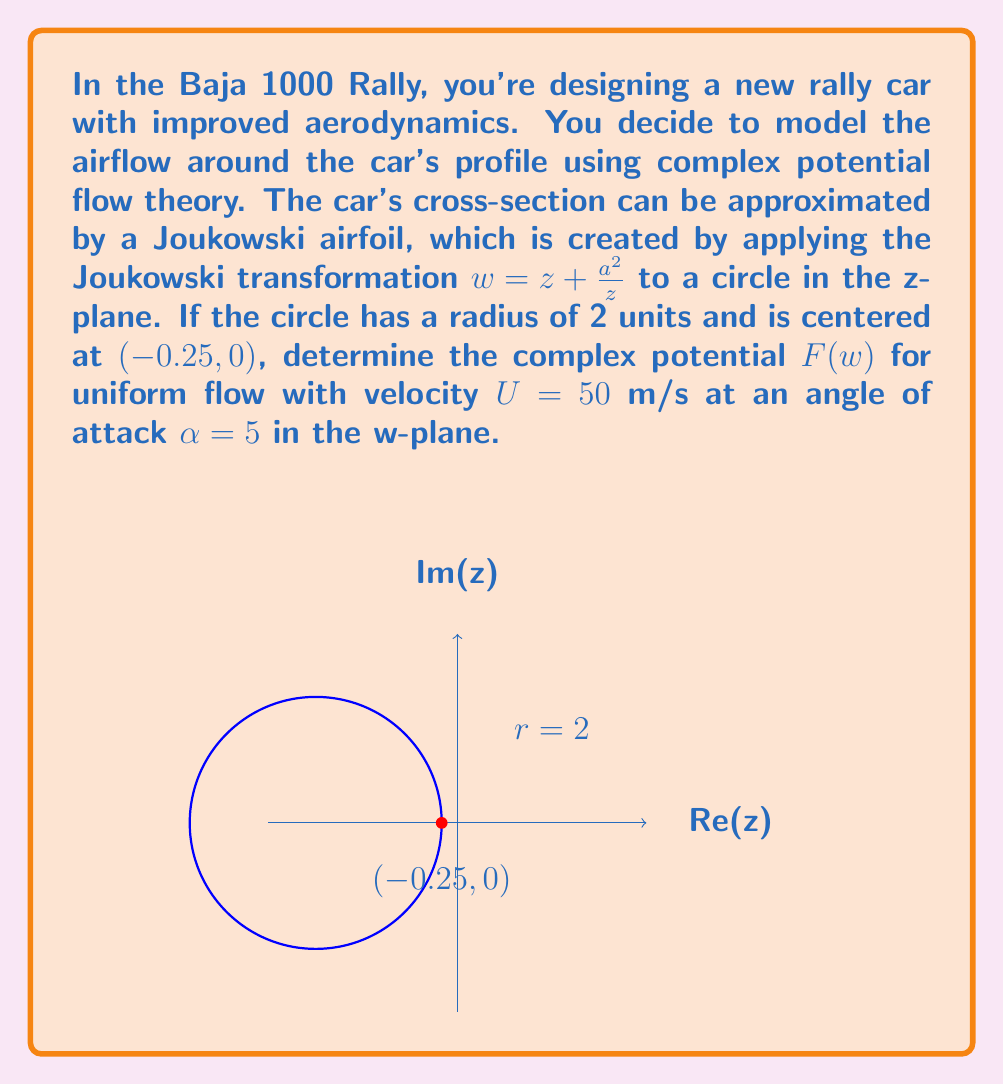Can you solve this math problem? Let's approach this step-by-step:

1) First, we need to find the complex potential in the z-plane. For uniform flow around a circle, the complex potential is given by:

   $$F(z) = U(z e^{-i\alpha} + \frac{R^2}{z} e^{i\alpha})$$

   where R is the radius of the circle and $\alpha$ is the angle of attack.

2) In our case, R = 2, U = 50 m/s, and $\alpha = 5° = \frac{\pi}{36}$ radians.

3) Substituting these values:

   $$F(z) = 50(z e^{-i\pi/36} + \frac{4}{z} e^{i\pi/36})$$

4) Now, we need to transform this to the w-plane using the Joukowski transformation:

   $$w = z + \frac{a^2}{z}$$

5) To find 'a', we use the fact that the circle is centered at (-0.25, 0) and has a radius of 2. The Joukowski transformation maps this to an airfoil if:

   $$a^2 = R(R-c) = 2(2-0.25) = 3.5$$

   So, $a = \sqrt{3.5} \approx 1.87$

6) To express F in terms of w, we need to invert the Joukowski transformation:

   $$z = \frac{w}{2} \pm \sqrt{\frac{w^2}{4} - a^2}$$

7) Choosing the '+' solution (as it corresponds to the exterior of the airfoil), we get:

   $$z = \frac{w}{2} + \sqrt{\frac{w^2}{4} - 3.5}$$

8) Substituting this into our expression for F(z):

   $$F(w) = 50((\frac{w}{2} + \sqrt{\frac{w^2}{4} - 3.5}) e^{-i\pi/36} + \frac{4}{\frac{w}{2} + \sqrt{\frac{w^2}{4} - 3.5}} e^{i\pi/36})$$

This is the complex potential in the w-plane, describing the flow around the Joukowski airfoil.
Answer: $$F(w) = 50((\frac{w}{2} + \sqrt{\frac{w^2}{4} - 3.5}) e^{-i\pi/36} + \frac{4}{\frac{w}{2} + \sqrt{\frac{w^2}{4} - 3.5}} e^{i\pi/36})$$ 